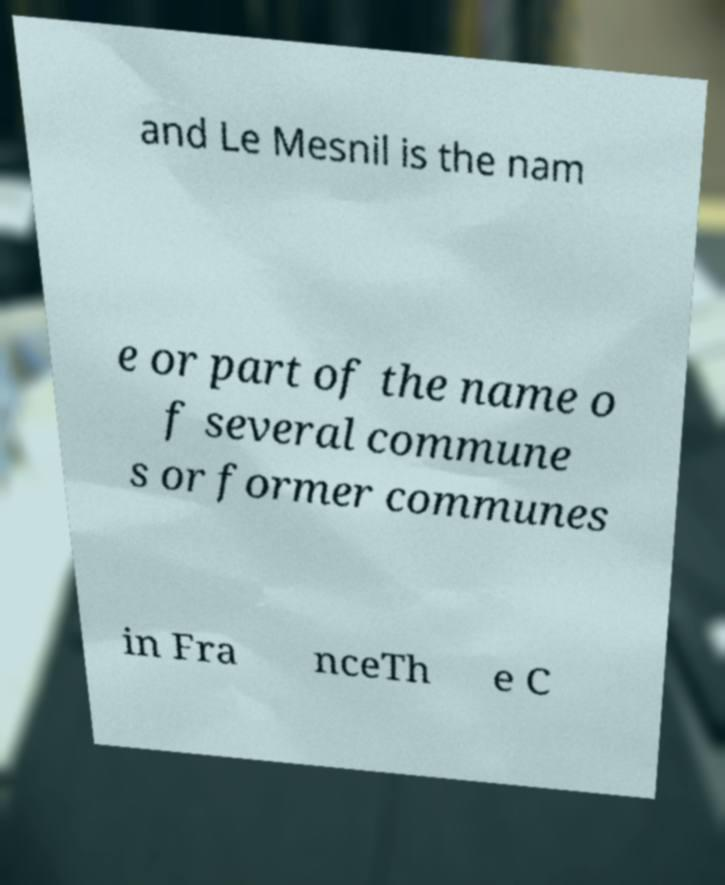Could you extract and type out the text from this image? and Le Mesnil is the nam e or part of the name o f several commune s or former communes in Fra nceTh e C 